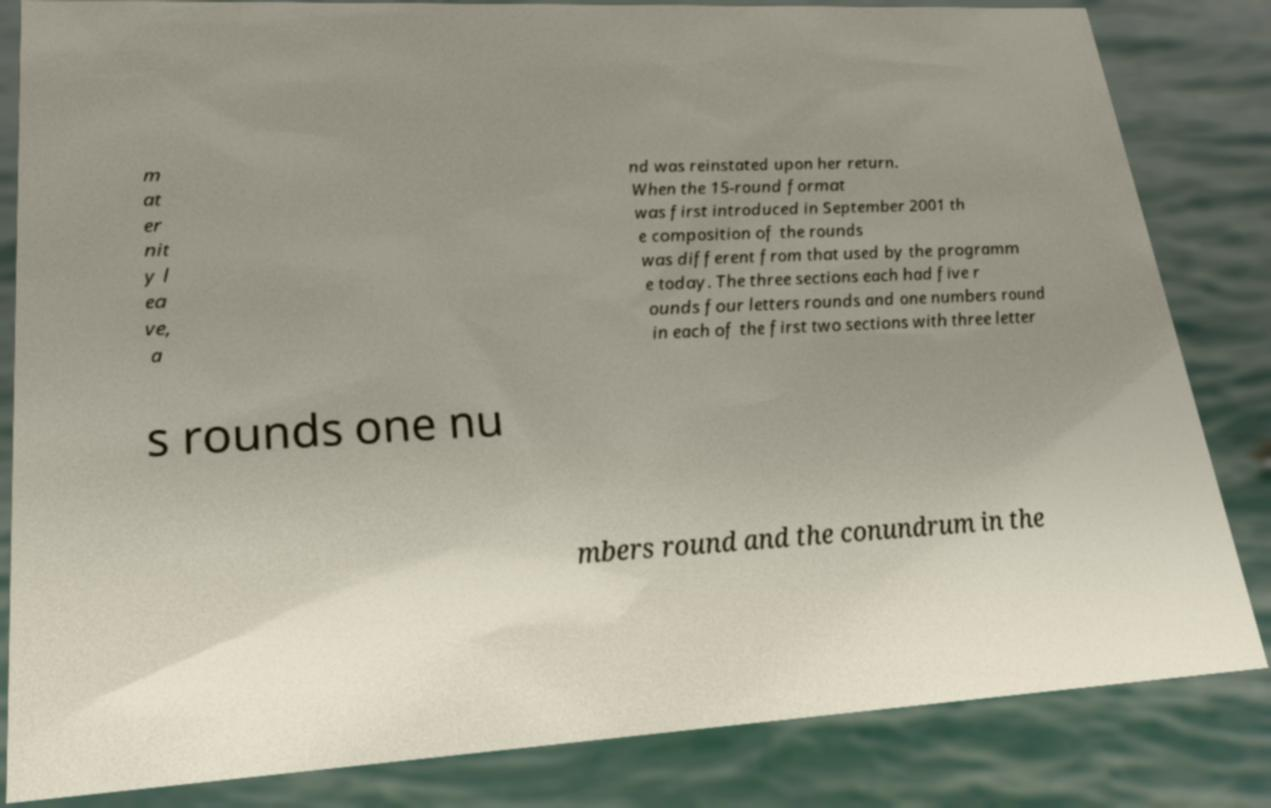What messages or text are displayed in this image? I need them in a readable, typed format. m at er nit y l ea ve, a nd was reinstated upon her return. When the 15-round format was first introduced in September 2001 th e composition of the rounds was different from that used by the programm e today. The three sections each had five r ounds four letters rounds and one numbers round in each of the first two sections with three letter s rounds one nu mbers round and the conundrum in the 